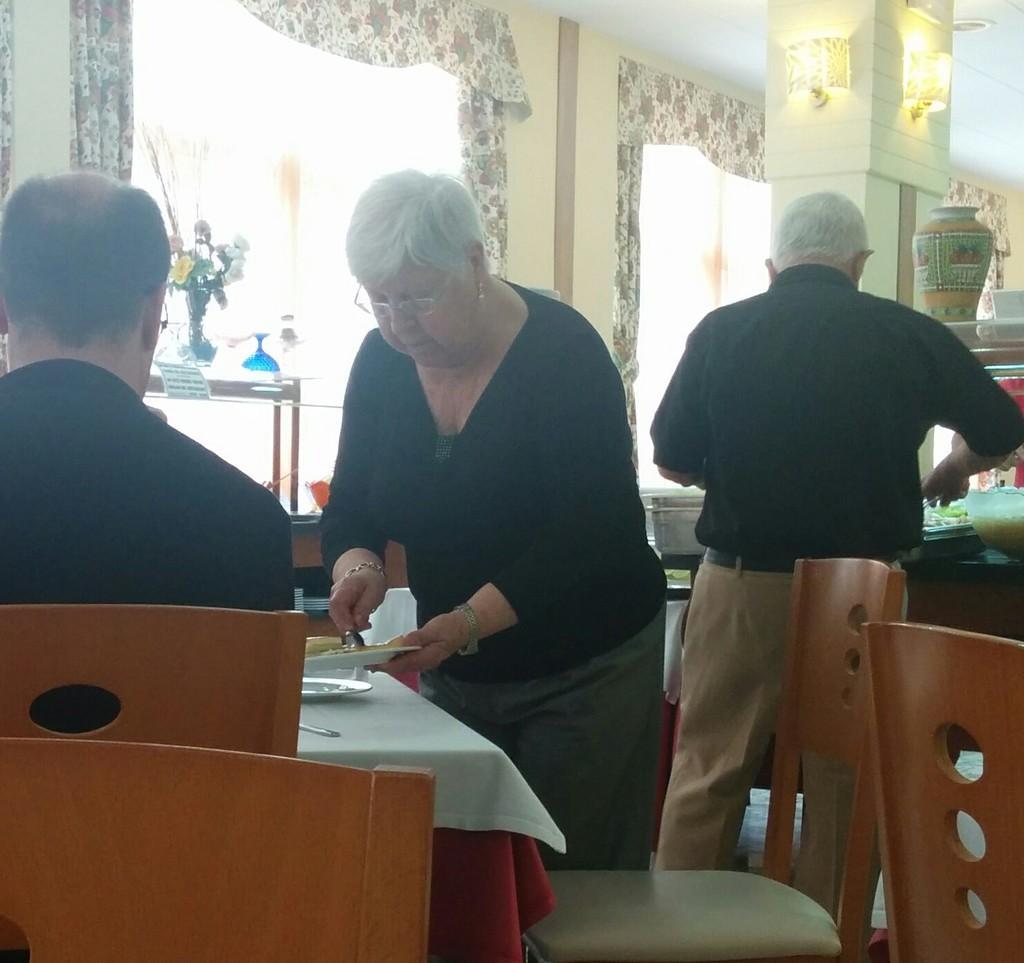Could you give a brief overview of what you see in this image? In this image there is a man who is sitting in the chair and a woman who is standing beside him is serving the food on the plate which is on the table. Beside the woman there is another man who is standing. At the background there is flower vase,window and the curtain. At the top there is light. 